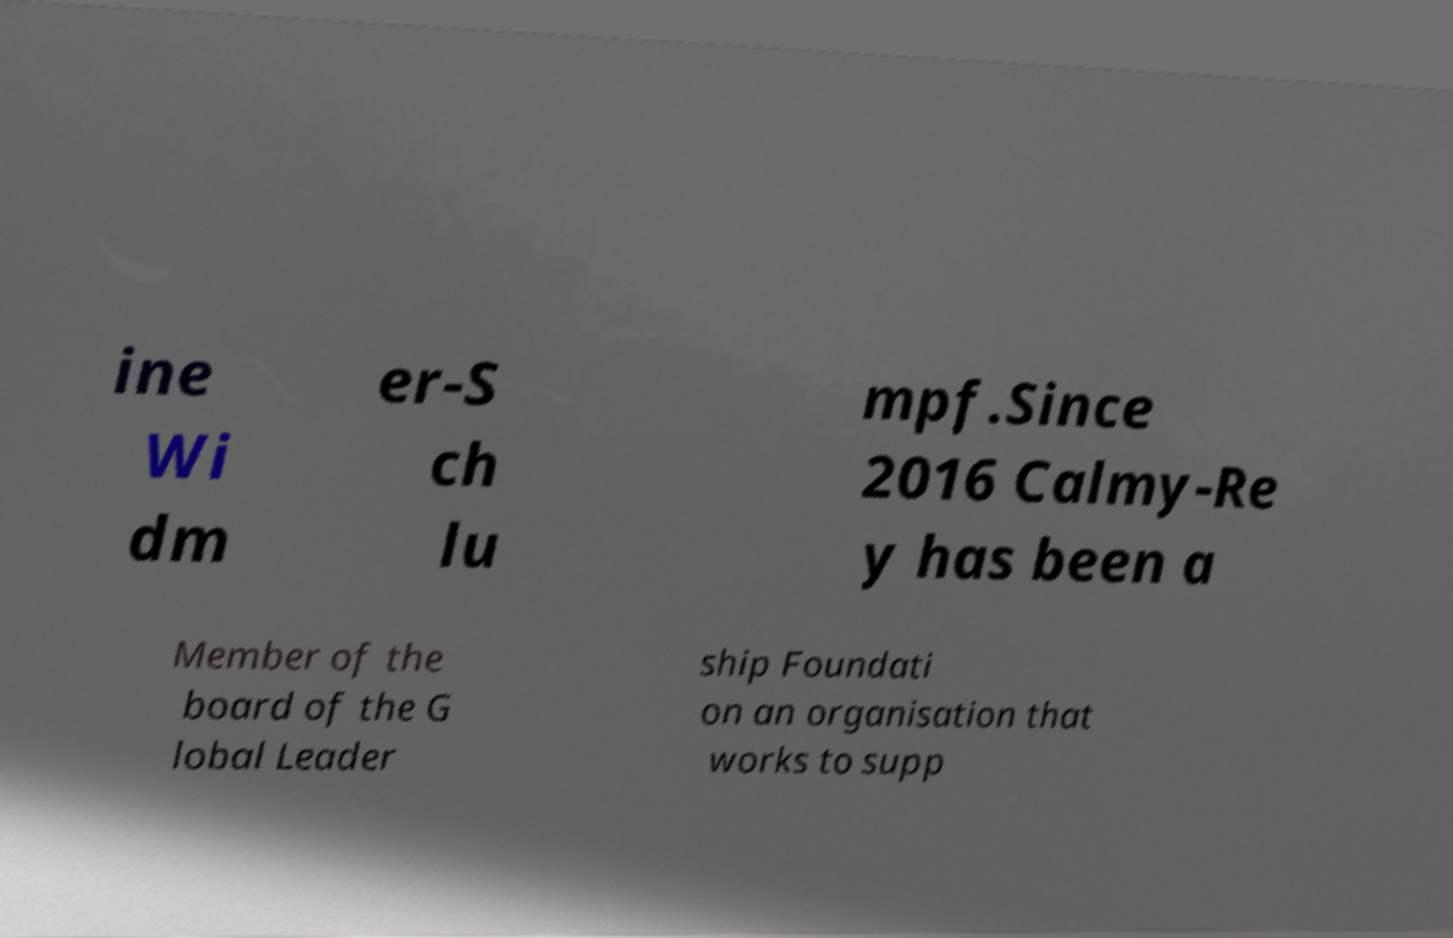Could you extract and type out the text from this image? ine Wi dm er-S ch lu mpf.Since 2016 Calmy-Re y has been a Member of the board of the G lobal Leader ship Foundati on an organisation that works to supp 